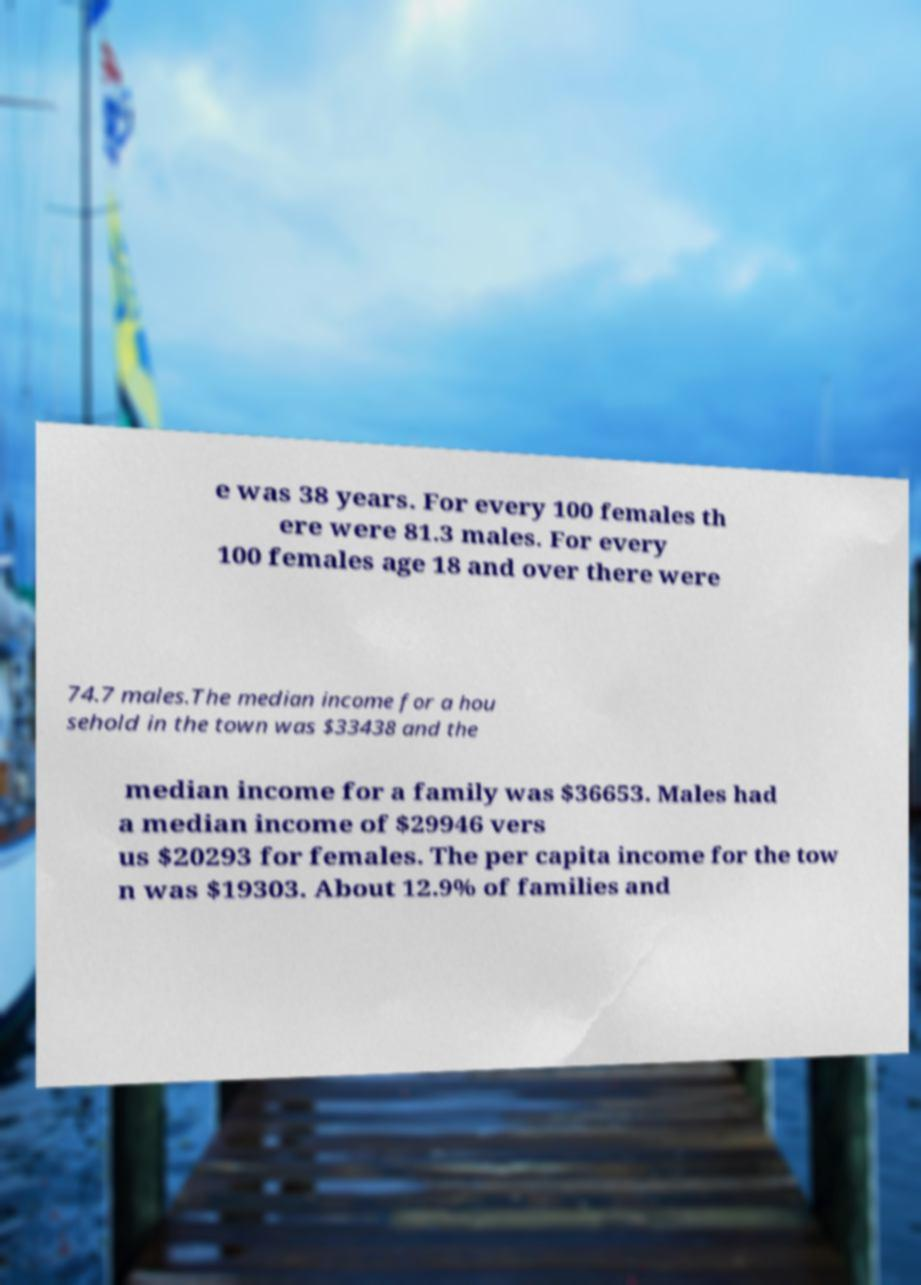What messages or text are displayed in this image? I need them in a readable, typed format. e was 38 years. For every 100 females th ere were 81.3 males. For every 100 females age 18 and over there were 74.7 males.The median income for a hou sehold in the town was $33438 and the median income for a family was $36653. Males had a median income of $29946 vers us $20293 for females. The per capita income for the tow n was $19303. About 12.9% of families and 